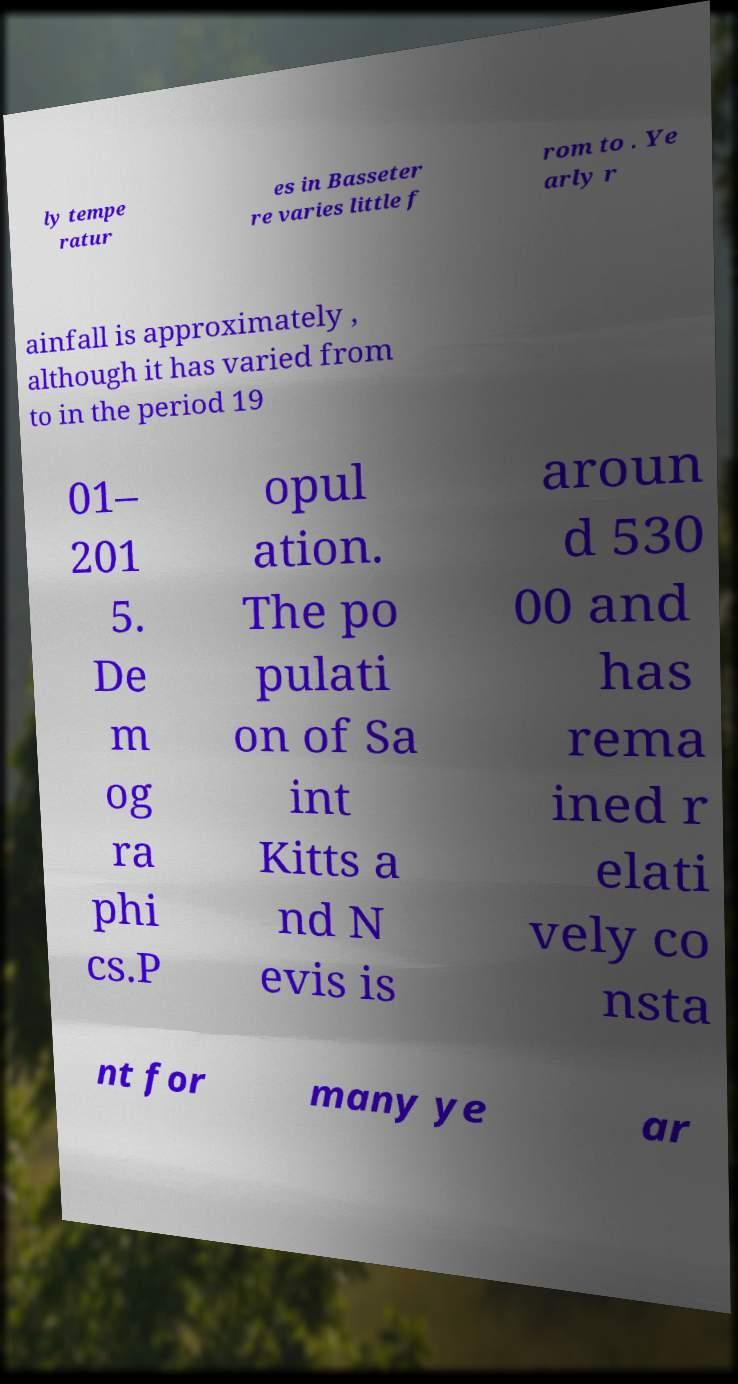Can you read and provide the text displayed in the image?This photo seems to have some interesting text. Can you extract and type it out for me? ly tempe ratur es in Basseter re varies little f rom to . Ye arly r ainfall is approximately , although it has varied from to in the period 19 01– 201 5. De m og ra phi cs.P opul ation. The po pulati on of Sa int Kitts a nd N evis is aroun d 530 00 and has rema ined r elati vely co nsta nt for many ye ar 